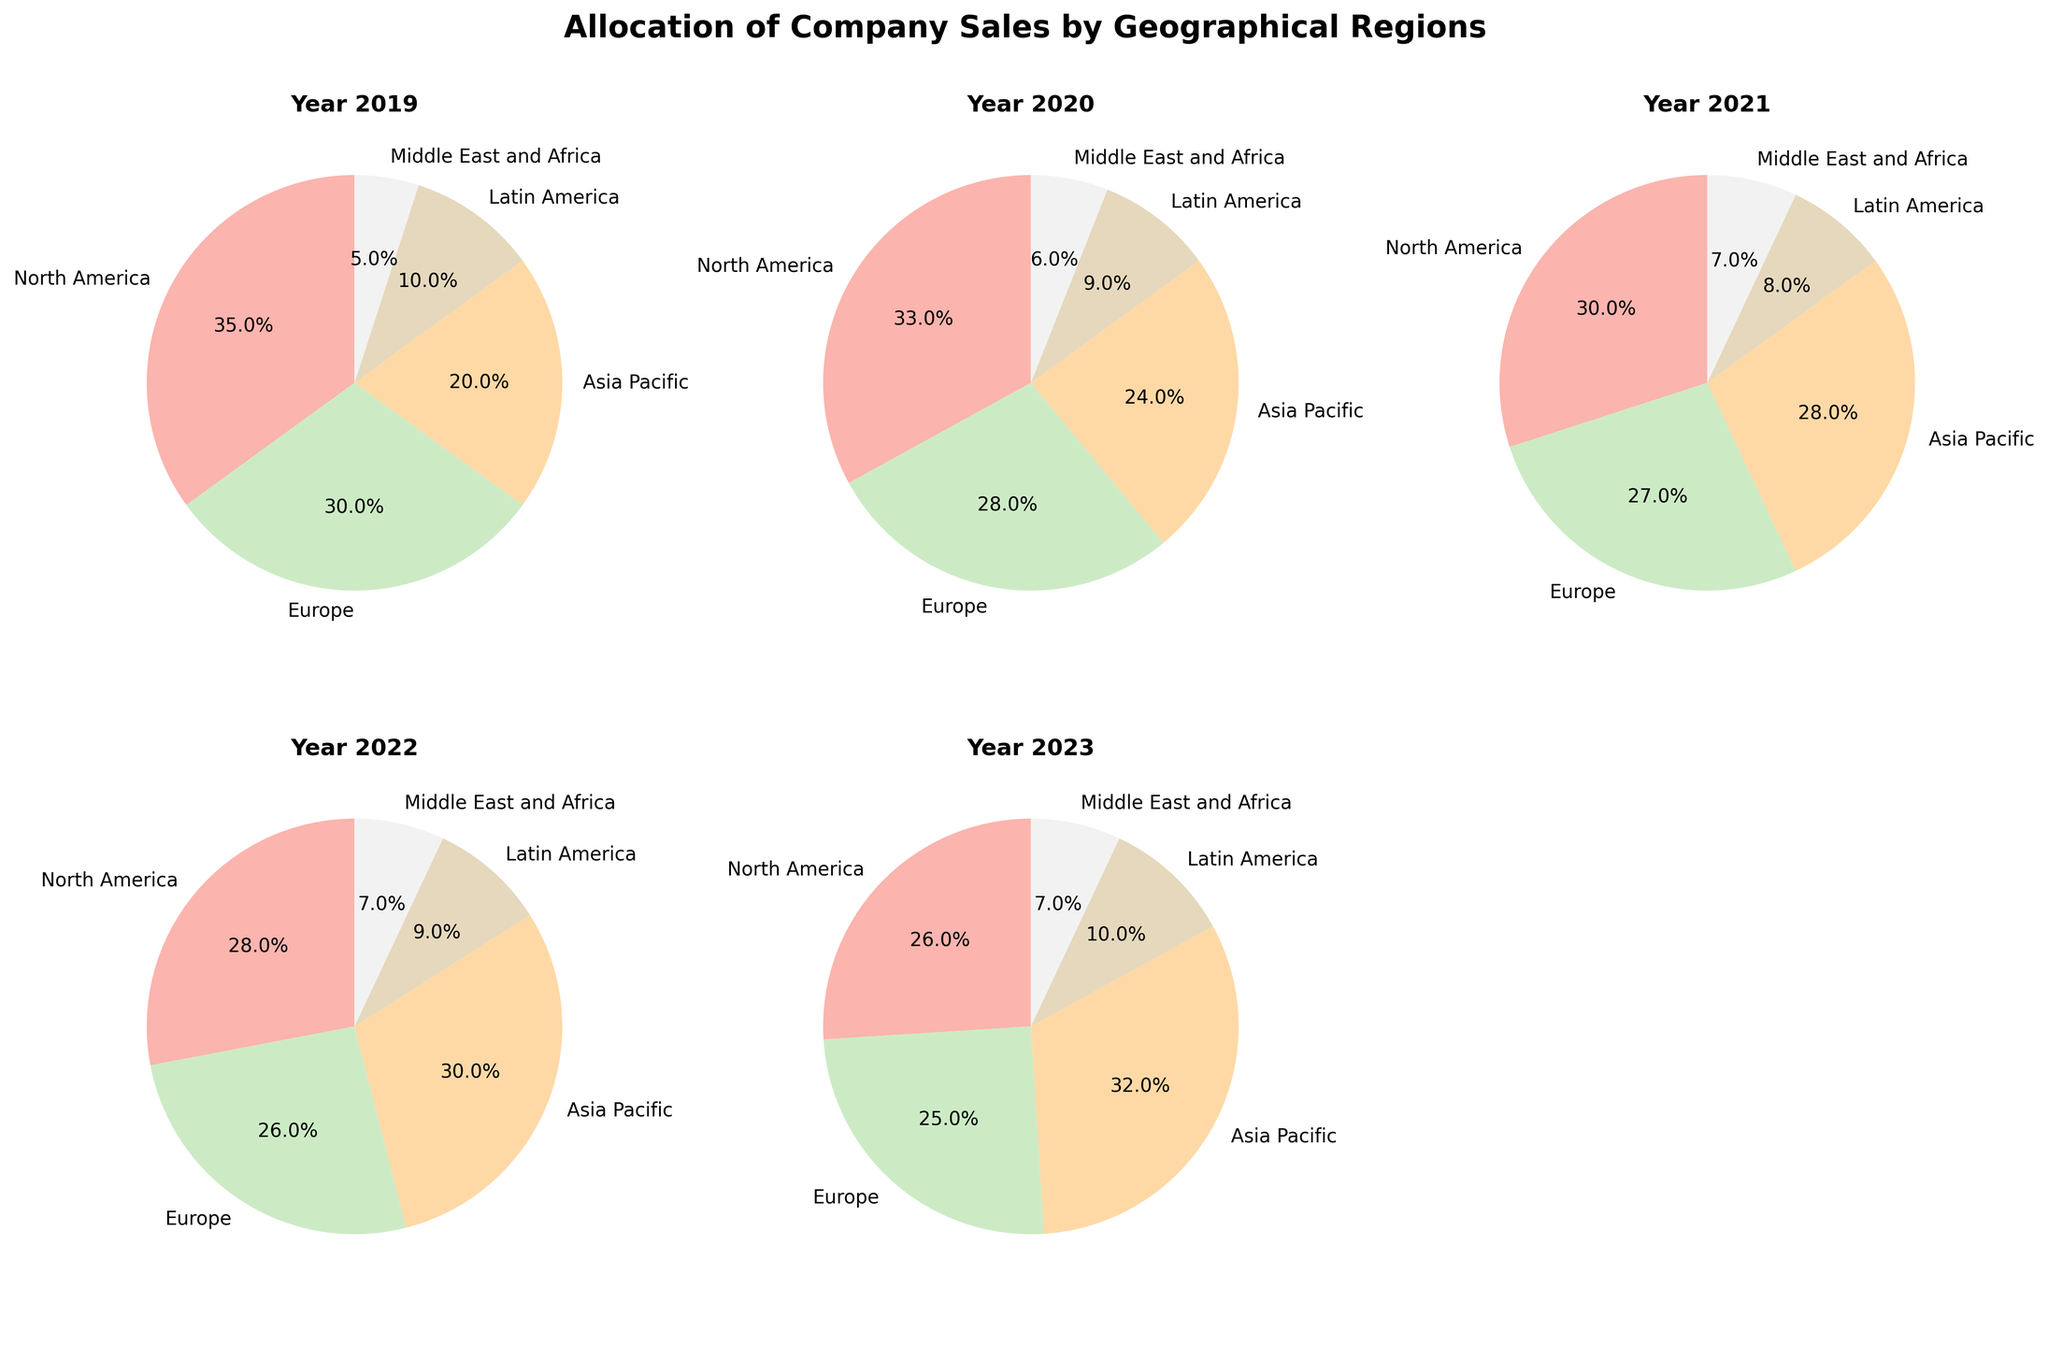What is the percentage of sales in North America in 2023? Look at the pie chart for the year 2023. North America's section should be labeled with the sales percentage.
Answer: 26% Which region had the largest increase in sales percentage from 2019 to 2023? Compare the percentage of each region between 2019 and 2023. The one with the largest positive difference has the largest increase. Asia Pacific went from 20% to 32%, which is the largest increase.
Answer: Asia Pacific In which year did Europe have the smallest percentage of total sales? Check the percentages of Europe across all pie charts for each year and identify the smallest value. Europe had its smallest percentage in 2023 with 25%.
Answer: 2023 How much did the sales percentage change for Latin America from 2019 to 2022? Subtract the 2019 percentage of Latin America from the 2022 percentage. The percentage shifted from 10% to 9%, a decrease.
Answer: -1% What is the average sales percentage for the Middle East and Africa from 2019 to 2023? Sum the percentages for Middle East and Africa over the years (5, 6, 7, 7, 7) and divide by the number of years (5). (5+6+7+7+7)/5 = 6.4%.
Answer: 6.4% In which year does North America have a lower sales percentage than Europe? Compare the percentages of North America and Europe for each year. North America has a lower percentage than Europe in all years except 2019 and 2020.
Answer: 2021, 2022, 2023 What is the sum of sales percentages for North America and Asia Pacific in 2022? Add the percentages of North America (28%) and Asia Pacific (30%) for 2022. 28+30 = 58%.
Answer: 58% Which region has had a steady sales percentage at 7% for multiple consecutive years? Look for a region with repeated identical percentages in consecutive years. The Middle East and Africa was at 7% from 2021 to 2023.
Answer: Middle East and Africa 